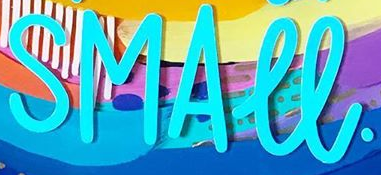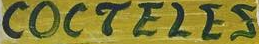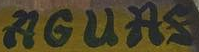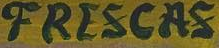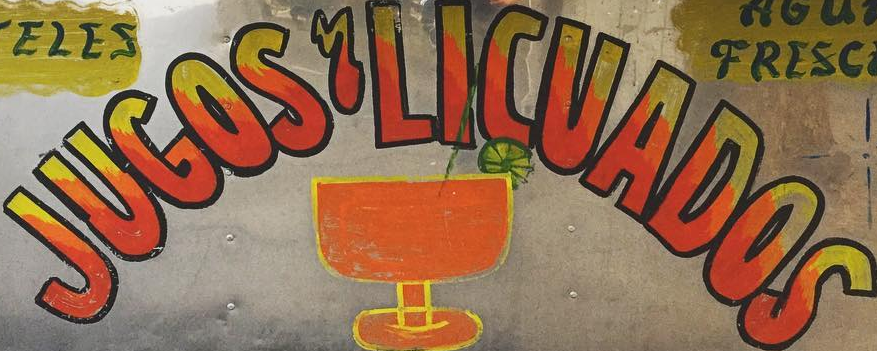What text appears in these images from left to right, separated by a semicolon? SMALL.; COCTELES; AGUAS; FRESCAS; JUGOS'LICUADOS 